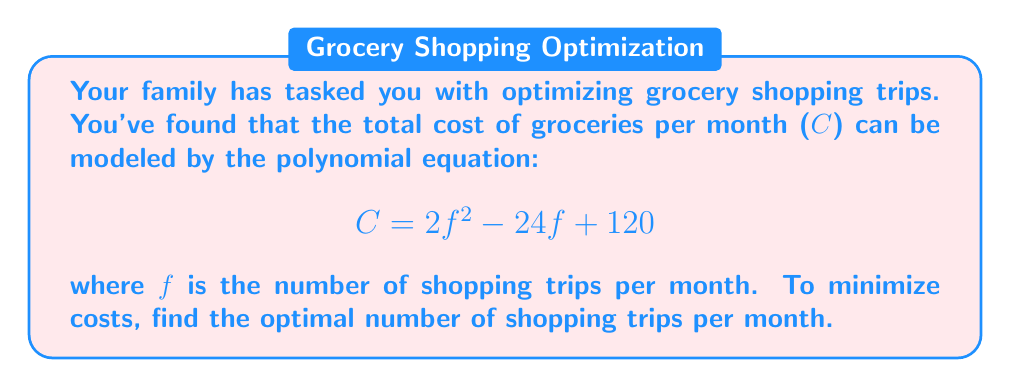Can you solve this math problem? To find the optimal number of shopping trips that minimizes costs, we need to find the minimum point of the quadratic function. This occurs at the axis of symmetry, which is also the root of the derivative of the function.

Step 1: Find the derivative of the cost function.
$$\frac{dC}{df} = 4f - 24$$

Step 2: Set the derivative equal to zero and solve for f.
$$4f - 24 = 0$$
$$4f = 24$$
$$f = 6$$

Step 3: Verify this is a minimum, not a maximum.
The coefficient of $f^2$ in the original equation is positive (2), so this parabola opens upward, confirming that f = 6 gives a minimum.

Step 4: Since f represents the number of shopping trips, it must be a whole number. We should check the integer values on either side of 6 to ensure 6 is indeed the optimal solution.

For f = 5: $C = 2(5^2) - 24(5) + 120 = 50 - 120 + 120 = 50$
For f = 6: $C = 2(6^2) - 24(6) + 120 = 72 - 144 + 120 = 48$
For f = 7: $C = 2(7^2) - 24(7) + 120 = 98 - 168 + 120 = 50$

This confirms that 6 shopping trips per month is indeed the optimal solution.
Answer: 6 trips per month 